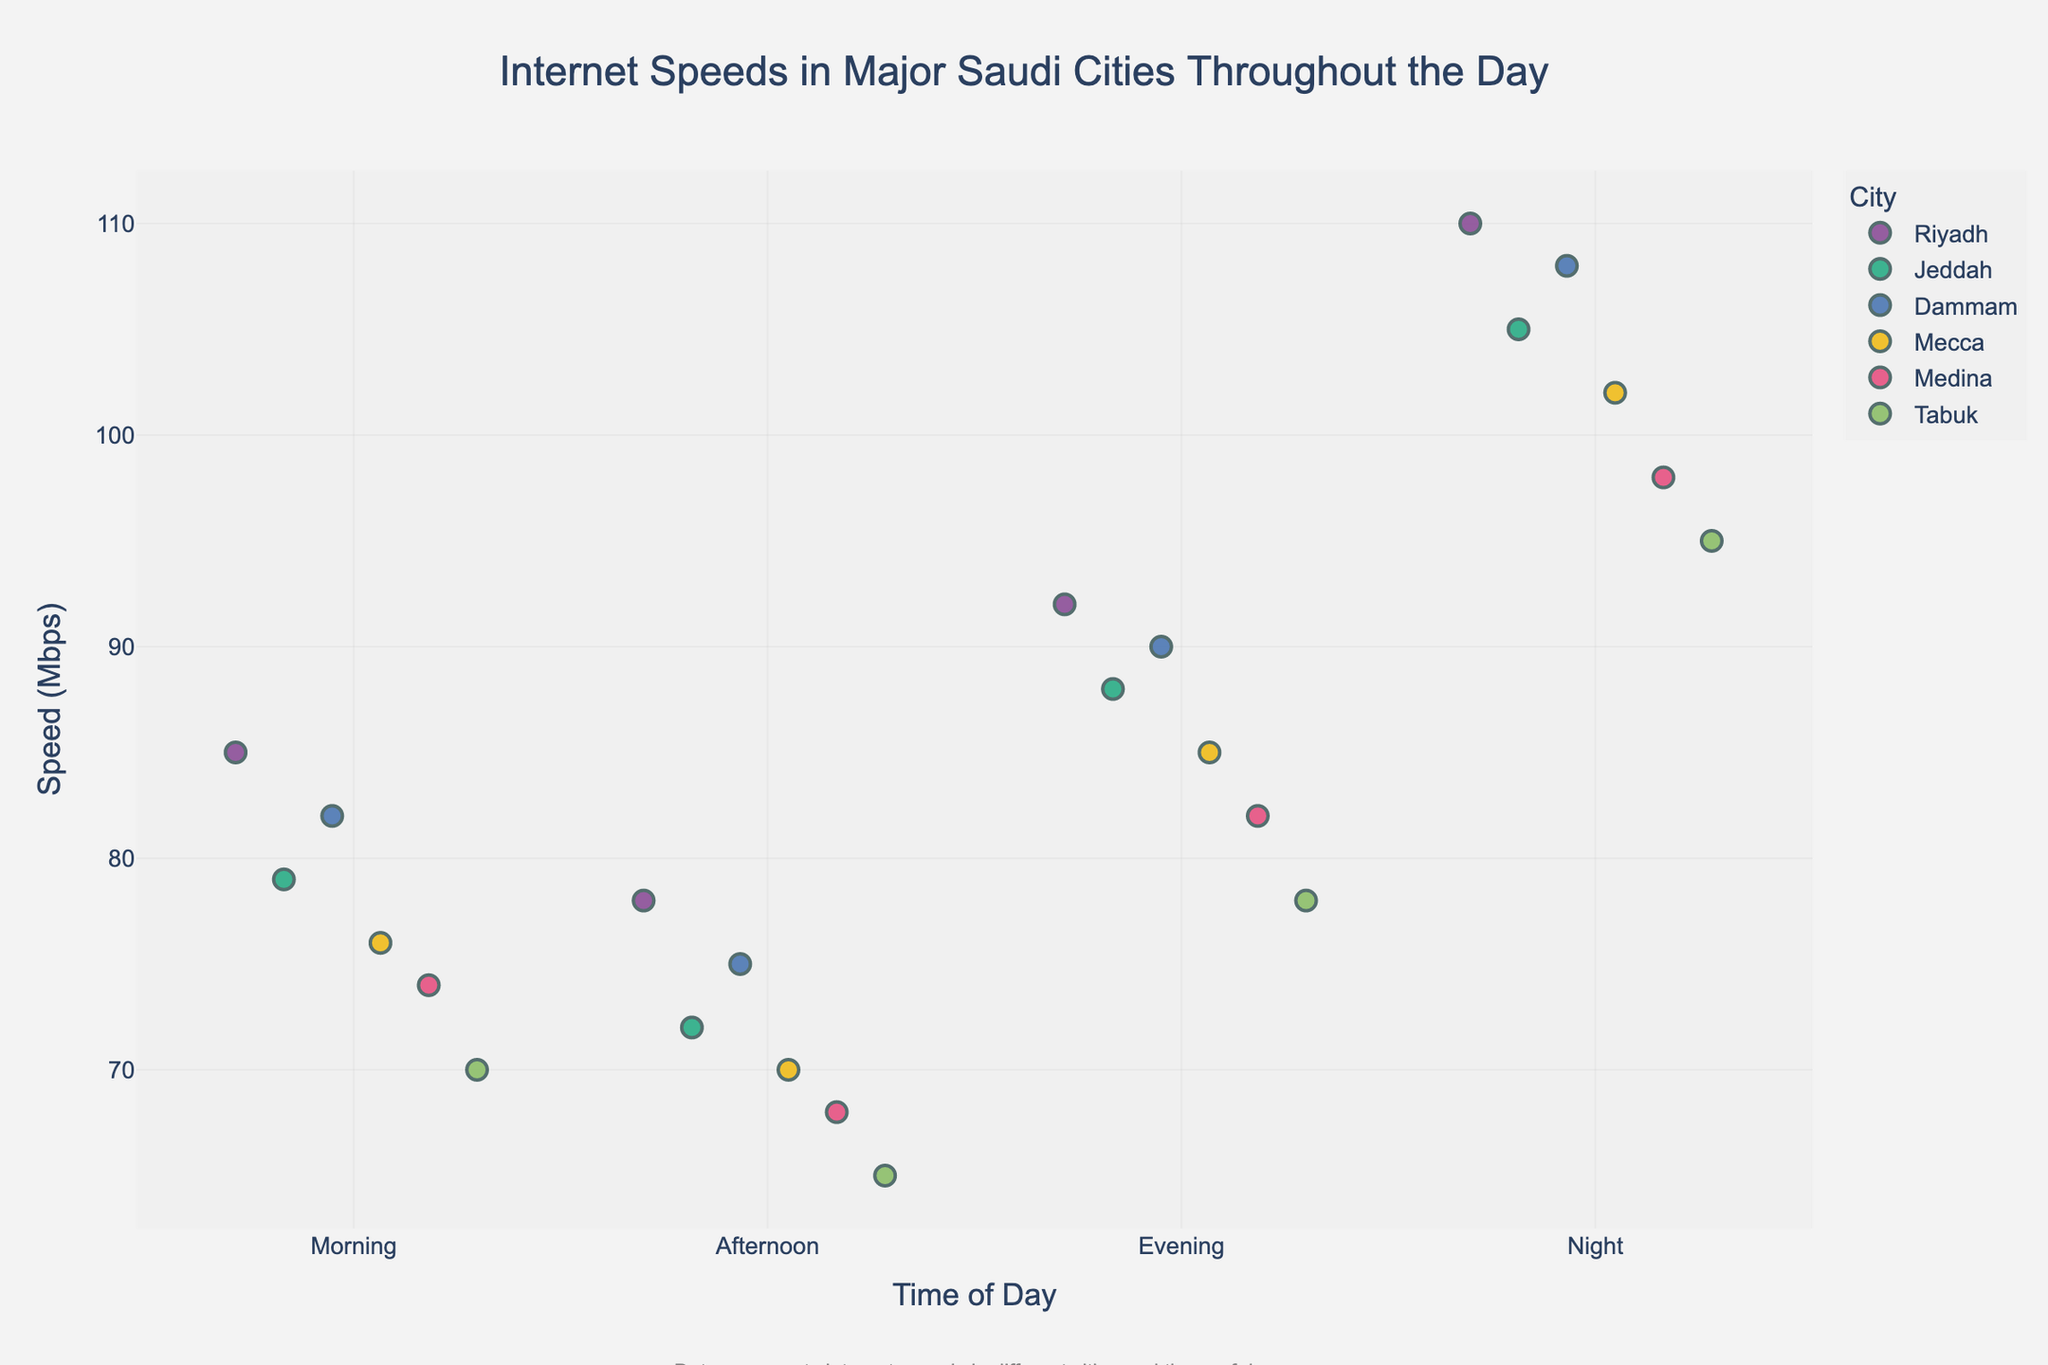What's the title of the figure? The title is located at the top of the figure and is usually larger in font size and centered for easy identification. Observing this area, we see it's clearly written.
Answer: Internet Speeds in Major Saudi Cities Throughout the Day Which city has the highest internet speed at night? By examining the 'Night' column and identifying the highest data point, we observe that Riyadh has the highest speed among the listed cities.
Answer: Riyadh How many times of the day are compared in the figure? The 'Time of Day' axis shows the different periods being compared. By counting the distinct labels along this axis, we determine the number.
Answer: 4 (Morning, Afternoon, Evening, Night) What is the range of internet speeds in Jeddah throughout the day? To find the range, observe the highest and lowest data points for Jeddah across all times of the day. Subtract the lowest speed from the highest speed to get the range.
Answer: 105 - 72 = 33 Mbps Which city shows a consistent increase in internet speed throughout the day? To determine consistency, check if the speeds for a particular city increase sequentially from Morning to Night. Examining each city's data reveals this pattern for Medina.
Answer: Medina What is the average internet speed in Dammam during the specified times? Add the internet speeds for Dammam during Morning, Afternoon, Evening, and Night, and then divide by the number of time periods (4).
Answer: (82 + 75 + 90 + 108) / 4 = 88.75 Mbps Which city has the lowest internet speed in the afternoon? Identify the lowest data point in the 'Afternoon' column and match it to the corresponding city. The lowest speed is 65 Mbps in Tabuk.
Answer: Tabuk Is there any time of day where all cities have internet speeds above 90 Mbps? To answer this, observe each city's speed at every time of day and check if there is a consistent value above 90 Mbps for all cities. No such time exists as speeds vary below 90 for some cities.
Answer: No 